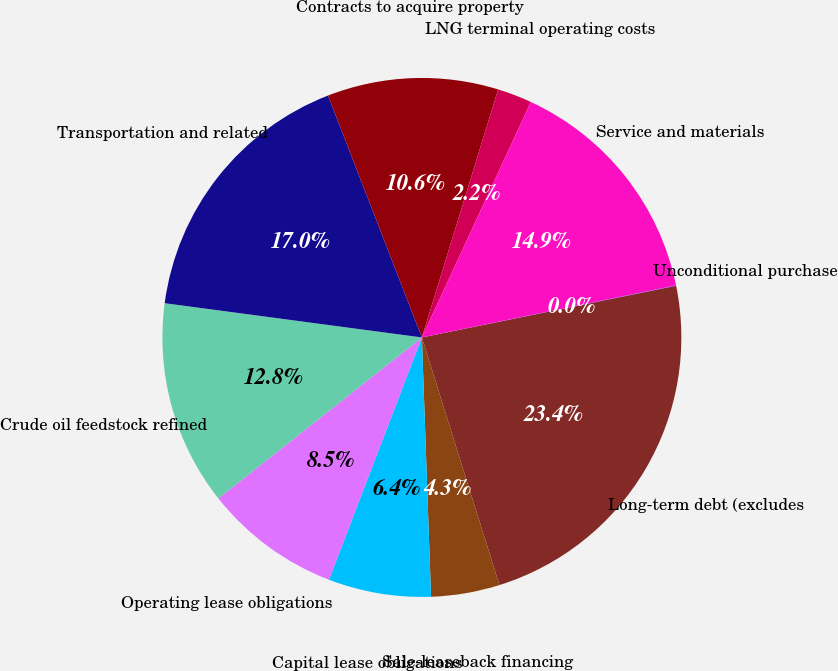Convert chart to OTSL. <chart><loc_0><loc_0><loc_500><loc_500><pie_chart><fcel>Long-term debt (excludes<fcel>Sale-leaseback financing<fcel>Capital lease obligations<fcel>Operating lease obligations<fcel>Crude oil feedstock refined<fcel>Transportation and related<fcel>Contracts to acquire property<fcel>LNG terminal operating costs<fcel>Service and materials<fcel>Unconditional purchase<nl><fcel>23.36%<fcel>4.27%<fcel>6.39%<fcel>8.52%<fcel>12.76%<fcel>17.0%<fcel>10.64%<fcel>2.15%<fcel>14.88%<fcel>0.03%<nl></chart> 